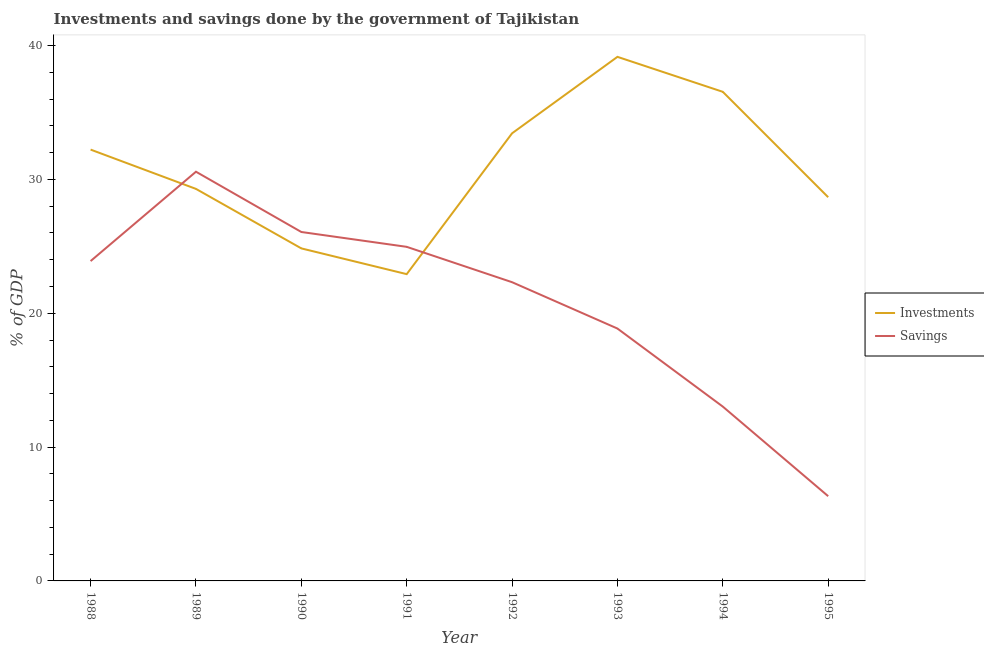Is the number of lines equal to the number of legend labels?
Give a very brief answer. Yes. What is the savings of government in 1994?
Provide a short and direct response. 13.02. Across all years, what is the maximum savings of government?
Ensure brevity in your answer.  30.57. Across all years, what is the minimum savings of government?
Offer a terse response. 6.33. What is the total investments of government in the graph?
Provide a short and direct response. 247.1. What is the difference between the investments of government in 1990 and that in 1993?
Offer a terse response. -14.31. What is the difference between the investments of government in 1991 and the savings of government in 1988?
Your response must be concise. -0.98. What is the average investments of government per year?
Provide a succinct answer. 30.89. In the year 1993, what is the difference between the savings of government and investments of government?
Provide a succinct answer. -20.3. What is the ratio of the savings of government in 1990 to that in 1994?
Offer a very short reply. 2. Is the investments of government in 1990 less than that in 1991?
Offer a terse response. No. Is the difference between the savings of government in 1988 and 1990 greater than the difference between the investments of government in 1988 and 1990?
Make the answer very short. No. What is the difference between the highest and the second highest savings of government?
Keep it short and to the point. 4.5. What is the difference between the highest and the lowest investments of government?
Offer a very short reply. 16.24. Is the sum of the investments of government in 1993 and 1995 greater than the maximum savings of government across all years?
Make the answer very short. Yes. Does the savings of government monotonically increase over the years?
Ensure brevity in your answer.  No. Is the investments of government strictly greater than the savings of government over the years?
Your answer should be very brief. No. What is the difference between two consecutive major ticks on the Y-axis?
Keep it short and to the point. 10. Are the values on the major ticks of Y-axis written in scientific E-notation?
Offer a very short reply. No. How many legend labels are there?
Provide a short and direct response. 2. What is the title of the graph?
Your response must be concise. Investments and savings done by the government of Tajikistan. What is the label or title of the X-axis?
Give a very brief answer. Year. What is the label or title of the Y-axis?
Ensure brevity in your answer.  % of GDP. What is the % of GDP of Investments in 1988?
Offer a very short reply. 32.23. What is the % of GDP of Savings in 1988?
Your response must be concise. 23.9. What is the % of GDP in Investments in 1989?
Offer a very short reply. 29.29. What is the % of GDP of Savings in 1989?
Your response must be concise. 30.57. What is the % of GDP in Investments in 1990?
Give a very brief answer. 24.84. What is the % of GDP in Savings in 1990?
Your answer should be very brief. 26.07. What is the % of GDP in Investments in 1991?
Provide a short and direct response. 22.92. What is the % of GDP in Savings in 1991?
Keep it short and to the point. 24.96. What is the % of GDP in Investments in 1992?
Your answer should be compact. 33.44. What is the % of GDP of Savings in 1992?
Your answer should be very brief. 22.32. What is the % of GDP of Investments in 1993?
Offer a very short reply. 39.16. What is the % of GDP of Savings in 1993?
Your answer should be very brief. 18.86. What is the % of GDP of Investments in 1994?
Keep it short and to the point. 36.54. What is the % of GDP in Savings in 1994?
Provide a short and direct response. 13.02. What is the % of GDP in Investments in 1995?
Keep it short and to the point. 28.67. What is the % of GDP in Savings in 1995?
Give a very brief answer. 6.33. Across all years, what is the maximum % of GDP of Investments?
Your response must be concise. 39.16. Across all years, what is the maximum % of GDP in Savings?
Your answer should be very brief. 30.57. Across all years, what is the minimum % of GDP in Investments?
Your answer should be compact. 22.92. Across all years, what is the minimum % of GDP of Savings?
Your answer should be very brief. 6.33. What is the total % of GDP of Investments in the graph?
Your response must be concise. 247.1. What is the total % of GDP in Savings in the graph?
Give a very brief answer. 166.04. What is the difference between the % of GDP in Investments in 1988 and that in 1989?
Provide a succinct answer. 2.94. What is the difference between the % of GDP of Savings in 1988 and that in 1989?
Provide a short and direct response. -6.68. What is the difference between the % of GDP of Investments in 1988 and that in 1990?
Provide a short and direct response. 7.38. What is the difference between the % of GDP of Savings in 1988 and that in 1990?
Offer a terse response. -2.17. What is the difference between the % of GDP in Investments in 1988 and that in 1991?
Offer a terse response. 9.31. What is the difference between the % of GDP of Savings in 1988 and that in 1991?
Offer a terse response. -1.06. What is the difference between the % of GDP of Investments in 1988 and that in 1992?
Your answer should be compact. -1.22. What is the difference between the % of GDP of Savings in 1988 and that in 1992?
Your answer should be compact. 1.58. What is the difference between the % of GDP of Investments in 1988 and that in 1993?
Give a very brief answer. -6.93. What is the difference between the % of GDP of Savings in 1988 and that in 1993?
Give a very brief answer. 5.04. What is the difference between the % of GDP of Investments in 1988 and that in 1994?
Keep it short and to the point. -4.32. What is the difference between the % of GDP in Savings in 1988 and that in 1994?
Offer a terse response. 10.87. What is the difference between the % of GDP in Investments in 1988 and that in 1995?
Offer a terse response. 3.56. What is the difference between the % of GDP of Savings in 1988 and that in 1995?
Offer a very short reply. 17.57. What is the difference between the % of GDP in Investments in 1989 and that in 1990?
Provide a succinct answer. 4.45. What is the difference between the % of GDP of Savings in 1989 and that in 1990?
Your answer should be very brief. 4.5. What is the difference between the % of GDP in Investments in 1989 and that in 1991?
Your response must be concise. 6.37. What is the difference between the % of GDP of Savings in 1989 and that in 1991?
Offer a terse response. 5.61. What is the difference between the % of GDP in Investments in 1989 and that in 1992?
Your answer should be compact. -4.15. What is the difference between the % of GDP in Savings in 1989 and that in 1992?
Ensure brevity in your answer.  8.25. What is the difference between the % of GDP of Investments in 1989 and that in 1993?
Offer a terse response. -9.87. What is the difference between the % of GDP of Savings in 1989 and that in 1993?
Give a very brief answer. 11.72. What is the difference between the % of GDP in Investments in 1989 and that in 1994?
Your response must be concise. -7.25. What is the difference between the % of GDP in Savings in 1989 and that in 1994?
Give a very brief answer. 17.55. What is the difference between the % of GDP in Investments in 1989 and that in 1995?
Your answer should be compact. 0.62. What is the difference between the % of GDP in Savings in 1989 and that in 1995?
Your answer should be compact. 24.24. What is the difference between the % of GDP in Investments in 1990 and that in 1991?
Your answer should be very brief. 1.92. What is the difference between the % of GDP in Savings in 1990 and that in 1991?
Offer a very short reply. 1.11. What is the difference between the % of GDP in Investments in 1990 and that in 1992?
Provide a short and direct response. -8.6. What is the difference between the % of GDP of Savings in 1990 and that in 1992?
Your answer should be very brief. 3.75. What is the difference between the % of GDP of Investments in 1990 and that in 1993?
Offer a very short reply. -14.31. What is the difference between the % of GDP of Savings in 1990 and that in 1993?
Provide a succinct answer. 7.21. What is the difference between the % of GDP of Investments in 1990 and that in 1994?
Your answer should be very brief. -11.7. What is the difference between the % of GDP of Savings in 1990 and that in 1994?
Make the answer very short. 13.05. What is the difference between the % of GDP in Investments in 1990 and that in 1995?
Provide a succinct answer. -3.82. What is the difference between the % of GDP of Savings in 1990 and that in 1995?
Offer a very short reply. 19.74. What is the difference between the % of GDP in Investments in 1991 and that in 1992?
Provide a succinct answer. -10.52. What is the difference between the % of GDP in Savings in 1991 and that in 1992?
Offer a terse response. 2.64. What is the difference between the % of GDP in Investments in 1991 and that in 1993?
Your answer should be very brief. -16.24. What is the difference between the % of GDP in Savings in 1991 and that in 1993?
Make the answer very short. 6.1. What is the difference between the % of GDP in Investments in 1991 and that in 1994?
Offer a very short reply. -13.62. What is the difference between the % of GDP in Savings in 1991 and that in 1994?
Give a very brief answer. 11.94. What is the difference between the % of GDP of Investments in 1991 and that in 1995?
Keep it short and to the point. -5.75. What is the difference between the % of GDP of Savings in 1991 and that in 1995?
Ensure brevity in your answer.  18.63. What is the difference between the % of GDP of Investments in 1992 and that in 1993?
Your answer should be very brief. -5.71. What is the difference between the % of GDP of Savings in 1992 and that in 1993?
Offer a terse response. 3.46. What is the difference between the % of GDP of Investments in 1992 and that in 1994?
Keep it short and to the point. -3.1. What is the difference between the % of GDP of Savings in 1992 and that in 1994?
Your answer should be compact. 9.29. What is the difference between the % of GDP of Investments in 1992 and that in 1995?
Offer a terse response. 4.78. What is the difference between the % of GDP of Savings in 1992 and that in 1995?
Provide a short and direct response. 15.99. What is the difference between the % of GDP of Investments in 1993 and that in 1994?
Your response must be concise. 2.61. What is the difference between the % of GDP of Savings in 1993 and that in 1994?
Your response must be concise. 5.83. What is the difference between the % of GDP of Investments in 1993 and that in 1995?
Provide a succinct answer. 10.49. What is the difference between the % of GDP in Savings in 1993 and that in 1995?
Offer a terse response. 12.53. What is the difference between the % of GDP in Investments in 1994 and that in 1995?
Give a very brief answer. 7.87. What is the difference between the % of GDP in Savings in 1994 and that in 1995?
Your answer should be compact. 6.69. What is the difference between the % of GDP of Investments in 1988 and the % of GDP of Savings in 1989?
Your answer should be compact. 1.65. What is the difference between the % of GDP in Investments in 1988 and the % of GDP in Savings in 1990?
Your answer should be very brief. 6.16. What is the difference between the % of GDP of Investments in 1988 and the % of GDP of Savings in 1991?
Offer a very short reply. 7.26. What is the difference between the % of GDP of Investments in 1988 and the % of GDP of Savings in 1992?
Your answer should be compact. 9.91. What is the difference between the % of GDP in Investments in 1988 and the % of GDP in Savings in 1993?
Offer a terse response. 13.37. What is the difference between the % of GDP of Investments in 1988 and the % of GDP of Savings in 1994?
Keep it short and to the point. 19.2. What is the difference between the % of GDP of Investments in 1988 and the % of GDP of Savings in 1995?
Offer a terse response. 25.9. What is the difference between the % of GDP in Investments in 1989 and the % of GDP in Savings in 1990?
Keep it short and to the point. 3.22. What is the difference between the % of GDP of Investments in 1989 and the % of GDP of Savings in 1991?
Make the answer very short. 4.33. What is the difference between the % of GDP in Investments in 1989 and the % of GDP in Savings in 1992?
Offer a terse response. 6.97. What is the difference between the % of GDP in Investments in 1989 and the % of GDP in Savings in 1993?
Provide a short and direct response. 10.43. What is the difference between the % of GDP in Investments in 1989 and the % of GDP in Savings in 1994?
Your answer should be very brief. 16.27. What is the difference between the % of GDP in Investments in 1989 and the % of GDP in Savings in 1995?
Keep it short and to the point. 22.96. What is the difference between the % of GDP of Investments in 1990 and the % of GDP of Savings in 1991?
Keep it short and to the point. -0.12. What is the difference between the % of GDP of Investments in 1990 and the % of GDP of Savings in 1992?
Ensure brevity in your answer.  2.53. What is the difference between the % of GDP in Investments in 1990 and the % of GDP in Savings in 1993?
Offer a very short reply. 5.99. What is the difference between the % of GDP of Investments in 1990 and the % of GDP of Savings in 1994?
Offer a very short reply. 11.82. What is the difference between the % of GDP of Investments in 1990 and the % of GDP of Savings in 1995?
Provide a short and direct response. 18.51. What is the difference between the % of GDP of Investments in 1991 and the % of GDP of Savings in 1992?
Provide a short and direct response. 0.6. What is the difference between the % of GDP of Investments in 1991 and the % of GDP of Savings in 1993?
Your response must be concise. 4.06. What is the difference between the % of GDP of Investments in 1991 and the % of GDP of Savings in 1994?
Offer a very short reply. 9.9. What is the difference between the % of GDP in Investments in 1991 and the % of GDP in Savings in 1995?
Keep it short and to the point. 16.59. What is the difference between the % of GDP in Investments in 1992 and the % of GDP in Savings in 1993?
Provide a short and direct response. 14.59. What is the difference between the % of GDP in Investments in 1992 and the % of GDP in Savings in 1994?
Your answer should be very brief. 20.42. What is the difference between the % of GDP in Investments in 1992 and the % of GDP in Savings in 1995?
Keep it short and to the point. 27.11. What is the difference between the % of GDP of Investments in 1993 and the % of GDP of Savings in 1994?
Ensure brevity in your answer.  26.13. What is the difference between the % of GDP of Investments in 1993 and the % of GDP of Savings in 1995?
Your response must be concise. 32.83. What is the difference between the % of GDP of Investments in 1994 and the % of GDP of Savings in 1995?
Provide a succinct answer. 30.21. What is the average % of GDP of Investments per year?
Provide a succinct answer. 30.89. What is the average % of GDP of Savings per year?
Keep it short and to the point. 20.75. In the year 1988, what is the difference between the % of GDP of Investments and % of GDP of Savings?
Ensure brevity in your answer.  8.33. In the year 1989, what is the difference between the % of GDP in Investments and % of GDP in Savings?
Keep it short and to the point. -1.28. In the year 1990, what is the difference between the % of GDP of Investments and % of GDP of Savings?
Your response must be concise. -1.23. In the year 1991, what is the difference between the % of GDP of Investments and % of GDP of Savings?
Keep it short and to the point. -2.04. In the year 1992, what is the difference between the % of GDP in Investments and % of GDP in Savings?
Offer a terse response. 11.12. In the year 1993, what is the difference between the % of GDP in Investments and % of GDP in Savings?
Your response must be concise. 20.3. In the year 1994, what is the difference between the % of GDP in Investments and % of GDP in Savings?
Provide a short and direct response. 23.52. In the year 1995, what is the difference between the % of GDP of Investments and % of GDP of Savings?
Offer a terse response. 22.34. What is the ratio of the % of GDP of Investments in 1988 to that in 1989?
Offer a very short reply. 1.1. What is the ratio of the % of GDP of Savings in 1988 to that in 1989?
Your response must be concise. 0.78. What is the ratio of the % of GDP in Investments in 1988 to that in 1990?
Give a very brief answer. 1.3. What is the ratio of the % of GDP in Savings in 1988 to that in 1990?
Ensure brevity in your answer.  0.92. What is the ratio of the % of GDP of Investments in 1988 to that in 1991?
Provide a short and direct response. 1.41. What is the ratio of the % of GDP in Savings in 1988 to that in 1991?
Give a very brief answer. 0.96. What is the ratio of the % of GDP of Investments in 1988 to that in 1992?
Keep it short and to the point. 0.96. What is the ratio of the % of GDP of Savings in 1988 to that in 1992?
Keep it short and to the point. 1.07. What is the ratio of the % of GDP of Investments in 1988 to that in 1993?
Ensure brevity in your answer.  0.82. What is the ratio of the % of GDP of Savings in 1988 to that in 1993?
Make the answer very short. 1.27. What is the ratio of the % of GDP in Investments in 1988 to that in 1994?
Make the answer very short. 0.88. What is the ratio of the % of GDP in Savings in 1988 to that in 1994?
Your answer should be very brief. 1.83. What is the ratio of the % of GDP in Investments in 1988 to that in 1995?
Keep it short and to the point. 1.12. What is the ratio of the % of GDP of Savings in 1988 to that in 1995?
Give a very brief answer. 3.77. What is the ratio of the % of GDP in Investments in 1989 to that in 1990?
Provide a short and direct response. 1.18. What is the ratio of the % of GDP of Savings in 1989 to that in 1990?
Provide a succinct answer. 1.17. What is the ratio of the % of GDP in Investments in 1989 to that in 1991?
Give a very brief answer. 1.28. What is the ratio of the % of GDP in Savings in 1989 to that in 1991?
Keep it short and to the point. 1.22. What is the ratio of the % of GDP in Investments in 1989 to that in 1992?
Your response must be concise. 0.88. What is the ratio of the % of GDP of Savings in 1989 to that in 1992?
Provide a short and direct response. 1.37. What is the ratio of the % of GDP of Investments in 1989 to that in 1993?
Give a very brief answer. 0.75. What is the ratio of the % of GDP of Savings in 1989 to that in 1993?
Provide a succinct answer. 1.62. What is the ratio of the % of GDP of Investments in 1989 to that in 1994?
Ensure brevity in your answer.  0.8. What is the ratio of the % of GDP in Savings in 1989 to that in 1994?
Offer a very short reply. 2.35. What is the ratio of the % of GDP of Investments in 1989 to that in 1995?
Keep it short and to the point. 1.02. What is the ratio of the % of GDP in Savings in 1989 to that in 1995?
Your answer should be very brief. 4.83. What is the ratio of the % of GDP in Investments in 1990 to that in 1991?
Make the answer very short. 1.08. What is the ratio of the % of GDP of Savings in 1990 to that in 1991?
Your answer should be compact. 1.04. What is the ratio of the % of GDP of Investments in 1990 to that in 1992?
Provide a succinct answer. 0.74. What is the ratio of the % of GDP in Savings in 1990 to that in 1992?
Make the answer very short. 1.17. What is the ratio of the % of GDP of Investments in 1990 to that in 1993?
Give a very brief answer. 0.63. What is the ratio of the % of GDP in Savings in 1990 to that in 1993?
Offer a terse response. 1.38. What is the ratio of the % of GDP in Investments in 1990 to that in 1994?
Your answer should be compact. 0.68. What is the ratio of the % of GDP in Savings in 1990 to that in 1994?
Offer a terse response. 2. What is the ratio of the % of GDP of Investments in 1990 to that in 1995?
Your answer should be very brief. 0.87. What is the ratio of the % of GDP in Savings in 1990 to that in 1995?
Give a very brief answer. 4.12. What is the ratio of the % of GDP of Investments in 1991 to that in 1992?
Ensure brevity in your answer.  0.69. What is the ratio of the % of GDP of Savings in 1991 to that in 1992?
Offer a very short reply. 1.12. What is the ratio of the % of GDP of Investments in 1991 to that in 1993?
Your response must be concise. 0.59. What is the ratio of the % of GDP of Savings in 1991 to that in 1993?
Your answer should be compact. 1.32. What is the ratio of the % of GDP of Investments in 1991 to that in 1994?
Your answer should be compact. 0.63. What is the ratio of the % of GDP in Savings in 1991 to that in 1994?
Your response must be concise. 1.92. What is the ratio of the % of GDP of Investments in 1991 to that in 1995?
Offer a terse response. 0.8. What is the ratio of the % of GDP of Savings in 1991 to that in 1995?
Offer a terse response. 3.94. What is the ratio of the % of GDP of Investments in 1992 to that in 1993?
Provide a succinct answer. 0.85. What is the ratio of the % of GDP in Savings in 1992 to that in 1993?
Offer a very short reply. 1.18. What is the ratio of the % of GDP of Investments in 1992 to that in 1994?
Offer a terse response. 0.92. What is the ratio of the % of GDP in Savings in 1992 to that in 1994?
Ensure brevity in your answer.  1.71. What is the ratio of the % of GDP of Investments in 1992 to that in 1995?
Offer a very short reply. 1.17. What is the ratio of the % of GDP of Savings in 1992 to that in 1995?
Keep it short and to the point. 3.53. What is the ratio of the % of GDP of Investments in 1993 to that in 1994?
Your response must be concise. 1.07. What is the ratio of the % of GDP in Savings in 1993 to that in 1994?
Provide a short and direct response. 1.45. What is the ratio of the % of GDP of Investments in 1993 to that in 1995?
Your answer should be compact. 1.37. What is the ratio of the % of GDP of Savings in 1993 to that in 1995?
Give a very brief answer. 2.98. What is the ratio of the % of GDP in Investments in 1994 to that in 1995?
Your answer should be compact. 1.27. What is the ratio of the % of GDP in Savings in 1994 to that in 1995?
Your response must be concise. 2.06. What is the difference between the highest and the second highest % of GDP in Investments?
Provide a succinct answer. 2.61. What is the difference between the highest and the second highest % of GDP of Savings?
Keep it short and to the point. 4.5. What is the difference between the highest and the lowest % of GDP in Investments?
Give a very brief answer. 16.24. What is the difference between the highest and the lowest % of GDP of Savings?
Make the answer very short. 24.24. 